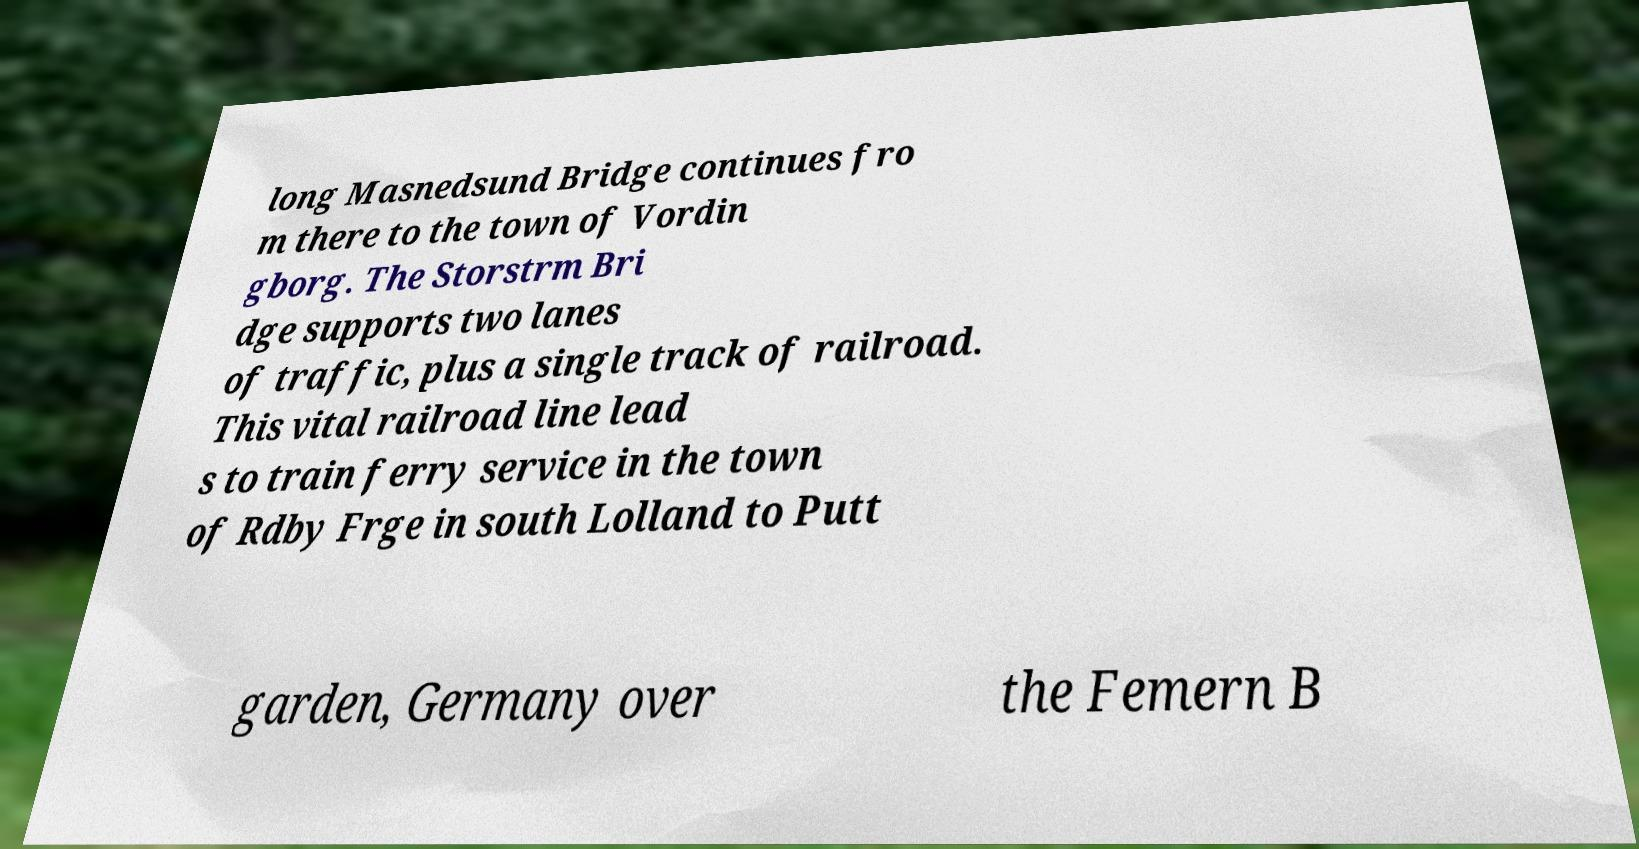Could you assist in decoding the text presented in this image and type it out clearly? long Masnedsund Bridge continues fro m there to the town of Vordin gborg. The Storstrm Bri dge supports two lanes of traffic, plus a single track of railroad. This vital railroad line lead s to train ferry service in the town of Rdby Frge in south Lolland to Putt garden, Germany over the Femern B 